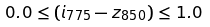<formula> <loc_0><loc_0><loc_500><loc_500>0 . 0 \leq ( i _ { 7 7 5 } - z _ { 8 5 0 } ) \leq 1 . 0</formula> 